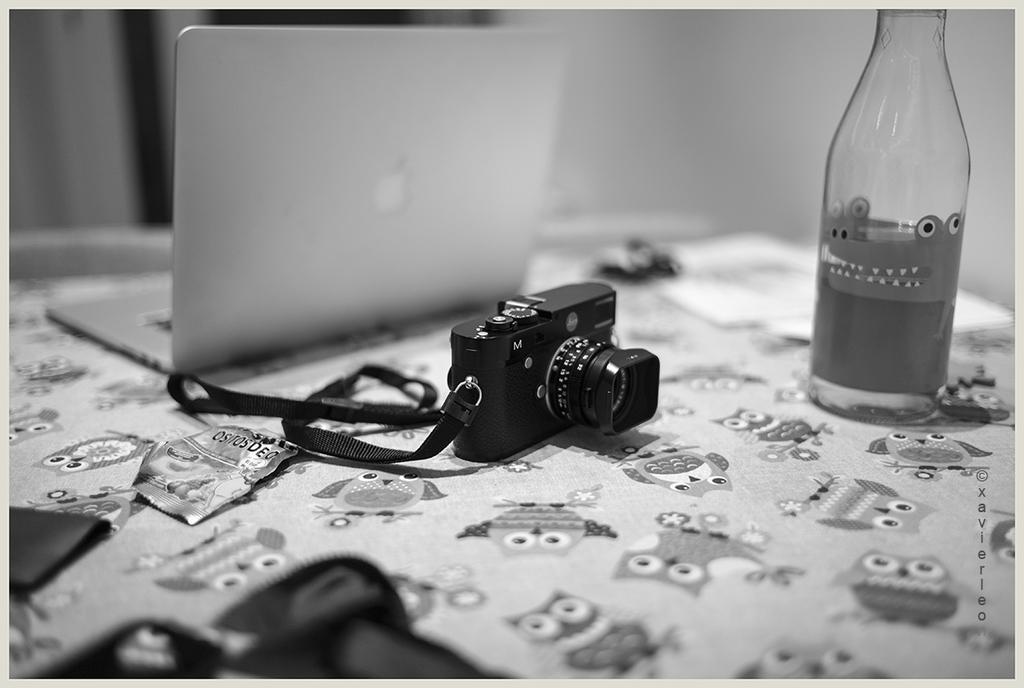Describe this image in one or two sentences. In this picture there is a camera placed on a table along with a laptop, bottle. 